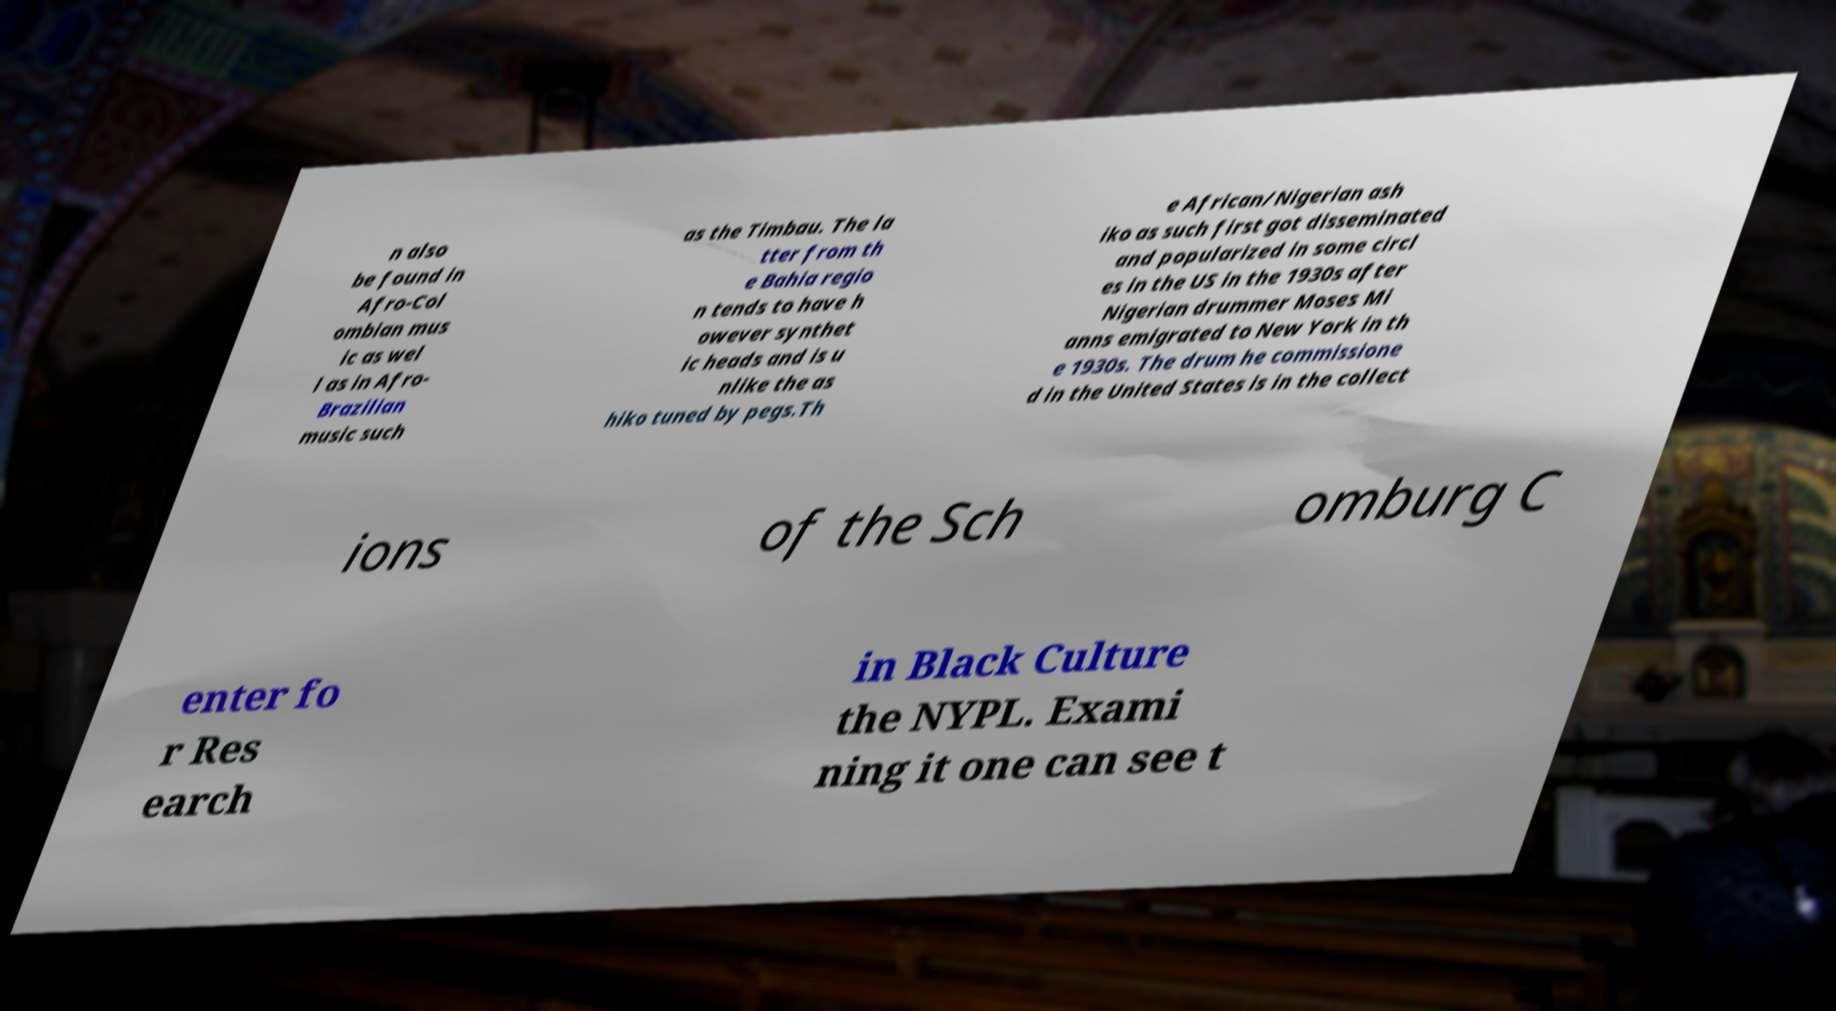I need the written content from this picture converted into text. Can you do that? n also be found in Afro-Col ombian mus ic as wel l as in Afro- Brazilian music such as the Timbau. The la tter from th e Bahia regio n tends to have h owever synthet ic heads and is u nlike the as hiko tuned by pegs.Th e African/Nigerian ash iko as such first got disseminated and popularized in some circl es in the US in the 1930s after Nigerian drummer Moses Mi anns emigrated to New York in th e 1930s. The drum he commissione d in the United States is in the collect ions of the Sch omburg C enter fo r Res earch in Black Culture the NYPL. Exami ning it one can see t 